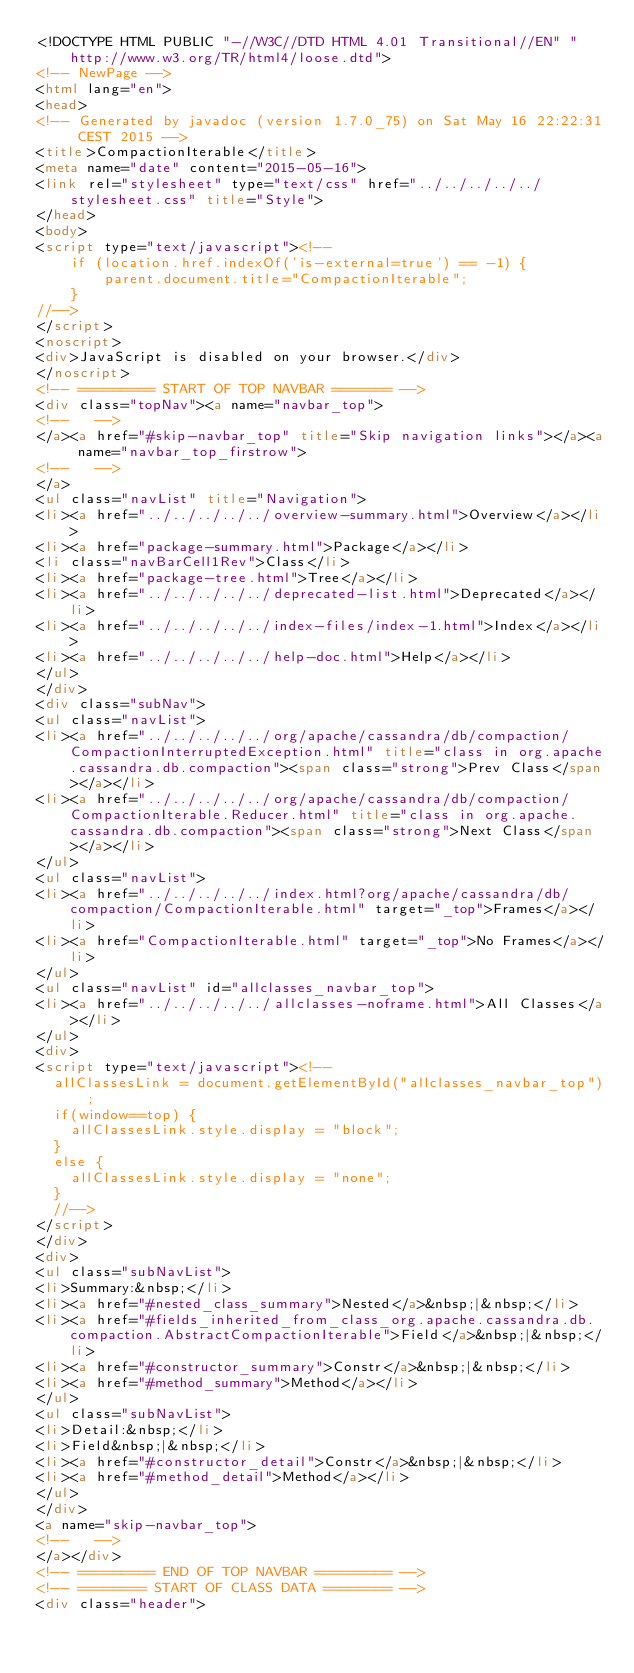Convert code to text. <code><loc_0><loc_0><loc_500><loc_500><_HTML_><!DOCTYPE HTML PUBLIC "-//W3C//DTD HTML 4.01 Transitional//EN" "http://www.w3.org/TR/html4/loose.dtd">
<!-- NewPage -->
<html lang="en">
<head>
<!-- Generated by javadoc (version 1.7.0_75) on Sat May 16 22:22:31 CEST 2015 -->
<title>CompactionIterable</title>
<meta name="date" content="2015-05-16">
<link rel="stylesheet" type="text/css" href="../../../../../stylesheet.css" title="Style">
</head>
<body>
<script type="text/javascript"><!--
    if (location.href.indexOf('is-external=true') == -1) {
        parent.document.title="CompactionIterable";
    }
//-->
</script>
<noscript>
<div>JavaScript is disabled on your browser.</div>
</noscript>
<!-- ========= START OF TOP NAVBAR ======= -->
<div class="topNav"><a name="navbar_top">
<!--   -->
</a><a href="#skip-navbar_top" title="Skip navigation links"></a><a name="navbar_top_firstrow">
<!--   -->
</a>
<ul class="navList" title="Navigation">
<li><a href="../../../../../overview-summary.html">Overview</a></li>
<li><a href="package-summary.html">Package</a></li>
<li class="navBarCell1Rev">Class</li>
<li><a href="package-tree.html">Tree</a></li>
<li><a href="../../../../../deprecated-list.html">Deprecated</a></li>
<li><a href="../../../../../index-files/index-1.html">Index</a></li>
<li><a href="../../../../../help-doc.html">Help</a></li>
</ul>
</div>
<div class="subNav">
<ul class="navList">
<li><a href="../../../../../org/apache/cassandra/db/compaction/CompactionInterruptedException.html" title="class in org.apache.cassandra.db.compaction"><span class="strong">Prev Class</span></a></li>
<li><a href="../../../../../org/apache/cassandra/db/compaction/CompactionIterable.Reducer.html" title="class in org.apache.cassandra.db.compaction"><span class="strong">Next Class</span></a></li>
</ul>
<ul class="navList">
<li><a href="../../../../../index.html?org/apache/cassandra/db/compaction/CompactionIterable.html" target="_top">Frames</a></li>
<li><a href="CompactionIterable.html" target="_top">No Frames</a></li>
</ul>
<ul class="navList" id="allclasses_navbar_top">
<li><a href="../../../../../allclasses-noframe.html">All Classes</a></li>
</ul>
<div>
<script type="text/javascript"><!--
  allClassesLink = document.getElementById("allclasses_navbar_top");
  if(window==top) {
    allClassesLink.style.display = "block";
  }
  else {
    allClassesLink.style.display = "none";
  }
  //-->
</script>
</div>
<div>
<ul class="subNavList">
<li>Summary:&nbsp;</li>
<li><a href="#nested_class_summary">Nested</a>&nbsp;|&nbsp;</li>
<li><a href="#fields_inherited_from_class_org.apache.cassandra.db.compaction.AbstractCompactionIterable">Field</a>&nbsp;|&nbsp;</li>
<li><a href="#constructor_summary">Constr</a>&nbsp;|&nbsp;</li>
<li><a href="#method_summary">Method</a></li>
</ul>
<ul class="subNavList">
<li>Detail:&nbsp;</li>
<li>Field&nbsp;|&nbsp;</li>
<li><a href="#constructor_detail">Constr</a>&nbsp;|&nbsp;</li>
<li><a href="#method_detail">Method</a></li>
</ul>
</div>
<a name="skip-navbar_top">
<!--   -->
</a></div>
<!-- ========= END OF TOP NAVBAR ========= -->
<!-- ======== START OF CLASS DATA ======== -->
<div class="header"></code> 